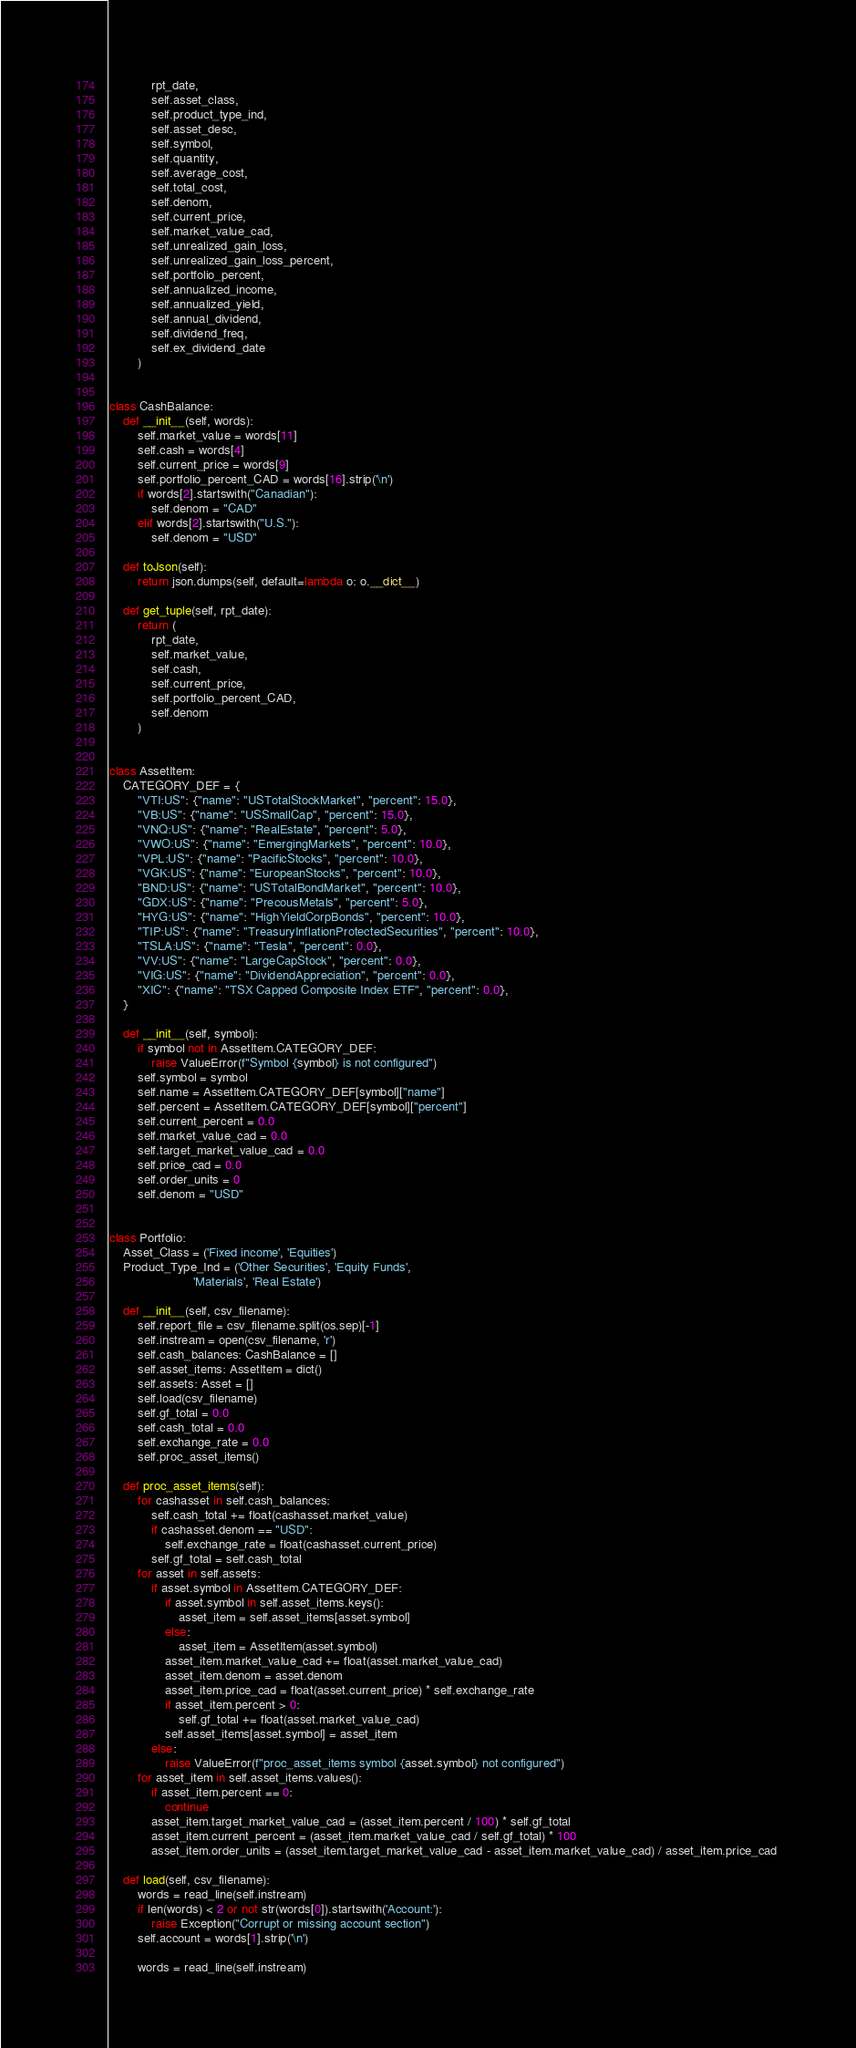Convert code to text. <code><loc_0><loc_0><loc_500><loc_500><_Python_>            rpt_date,
            self.asset_class,
            self.product_type_ind,
            self.asset_desc,
            self.symbol,
            self.quantity,
            self.average_cost,
            self.total_cost,
            self.denom,
            self.current_price,
            self.market_value_cad,
            self.unrealized_gain_loss,
            self.unrealized_gain_loss_percent,
            self.portfolio_percent,
            self.annualized_income,
            self.annualized_yield,
            self.annual_dividend,
            self.dividend_freq,
            self.ex_dividend_date
        )


class CashBalance:
    def __init__(self, words):
        self.market_value = words[11]
        self.cash = words[4]
        self.current_price = words[9]
        self.portfolio_percent_CAD = words[16].strip('\n')
        if words[2].startswith("Canadian"):
            self.denom = "CAD"
        elif words[2].startswith("U.S."):
            self.denom = "USD"

    def toJson(self):
        return json.dumps(self, default=lambda o: o.__dict__)

    def get_tuple(self, rpt_date):
        return (
            rpt_date,
            self.market_value,
            self.cash,
            self.current_price,
            self.portfolio_percent_CAD,
            self.denom
        )


class AssetItem:
    CATEGORY_DEF = {
        "VTI:US": {"name": "USTotalStockMarket", "percent": 15.0},
        "VB:US": {"name": "USSmallCap", "percent": 15.0},
        "VNQ:US": {"name": "RealEstate", "percent": 5.0},
        "VWO:US": {"name": "EmergingMarkets", "percent": 10.0},
        "VPL:US": {"name": "PacificStocks", "percent": 10.0},
        "VGK:US": {"name": "EuropeanStocks", "percent": 10.0},
        "BND:US": {"name": "USTotalBondMarket", "percent": 10.0},
        "GDX:US": {"name": "PrecousMetals", "percent": 5.0},
        "HYG:US": {"name": "HighYieldCorpBonds", "percent": 10.0},
        "TIP:US": {"name": "TreasuryInflationProtectedSecurities", "percent": 10.0},
        "TSLA:US": {"name": "Tesla", "percent": 0.0},
        "VV:US": {"name": "LargeCapStock", "percent": 0.0},
        "VIG:US": {"name": "DividendAppreciation", "percent": 0.0},
        "XIC": {"name": "TSX Capped Composite Index ETF", "percent": 0.0},
    }

    def __init__(self, symbol):
        if symbol not in AssetItem.CATEGORY_DEF:
            raise ValueError(f"Symbol {symbol} is not configured")
        self.symbol = symbol
        self.name = AssetItem.CATEGORY_DEF[symbol]["name"]
        self.percent = AssetItem.CATEGORY_DEF[symbol]["percent"]
        self.current_percent = 0.0
        self.market_value_cad = 0.0
        self.target_market_value_cad = 0.0
        self.price_cad = 0.0
        self.order_units = 0
        self.denom = "USD"


class Portfolio:
    Asset_Class = ('Fixed income', 'Equities')
    Product_Type_Ind = ('Other Securities', 'Equity Funds',
                        'Materials', 'Real Estate')

    def __init__(self, csv_filename):
        self.report_file = csv_filename.split(os.sep)[-1]
        self.instream = open(csv_filename, 'r')
        self.cash_balances: CashBalance = []
        self.asset_items: AssetItem = dict()
        self.assets: Asset = []
        self.load(csv_filename)
        self.gf_total = 0.0
        self.cash_total = 0.0
        self.exchange_rate = 0.0
        self.proc_asset_items()

    def proc_asset_items(self):
        for cashasset in self.cash_balances:
            self.cash_total += float(cashasset.market_value)
            if cashasset.denom == "USD":
                self.exchange_rate = float(cashasset.current_price)
            self.gf_total = self.cash_total
        for asset in self.assets:
            if asset.symbol in AssetItem.CATEGORY_DEF:
                if asset.symbol in self.asset_items.keys():
                    asset_item = self.asset_items[asset.symbol]
                else:
                    asset_item = AssetItem(asset.symbol)
                asset_item.market_value_cad += float(asset.market_value_cad)
                asset_item.denom = asset.denom
                asset_item.price_cad = float(asset.current_price) * self.exchange_rate
                if asset_item.percent > 0:
                    self.gf_total += float(asset.market_value_cad)
                self.asset_items[asset.symbol] = asset_item
            else:
                raise ValueError(f"proc_asset_items symbol {asset.symbol} not configured")
        for asset_item in self.asset_items.values():
            if asset_item.percent == 0:
                continue
            asset_item.target_market_value_cad = (asset_item.percent / 100) * self.gf_total
            asset_item.current_percent = (asset_item.market_value_cad / self.gf_total) * 100
            asset_item.order_units = (asset_item.target_market_value_cad - asset_item.market_value_cad) / asset_item.price_cad 

    def load(self, csv_filename):
        words = read_line(self.instream)
        if len(words) < 2 or not str(words[0]).startswith('Account:'):
            raise Exception("Corrupt or missing account section")
        self.account = words[1].strip('\n')

        words = read_line(self.instream)</code> 